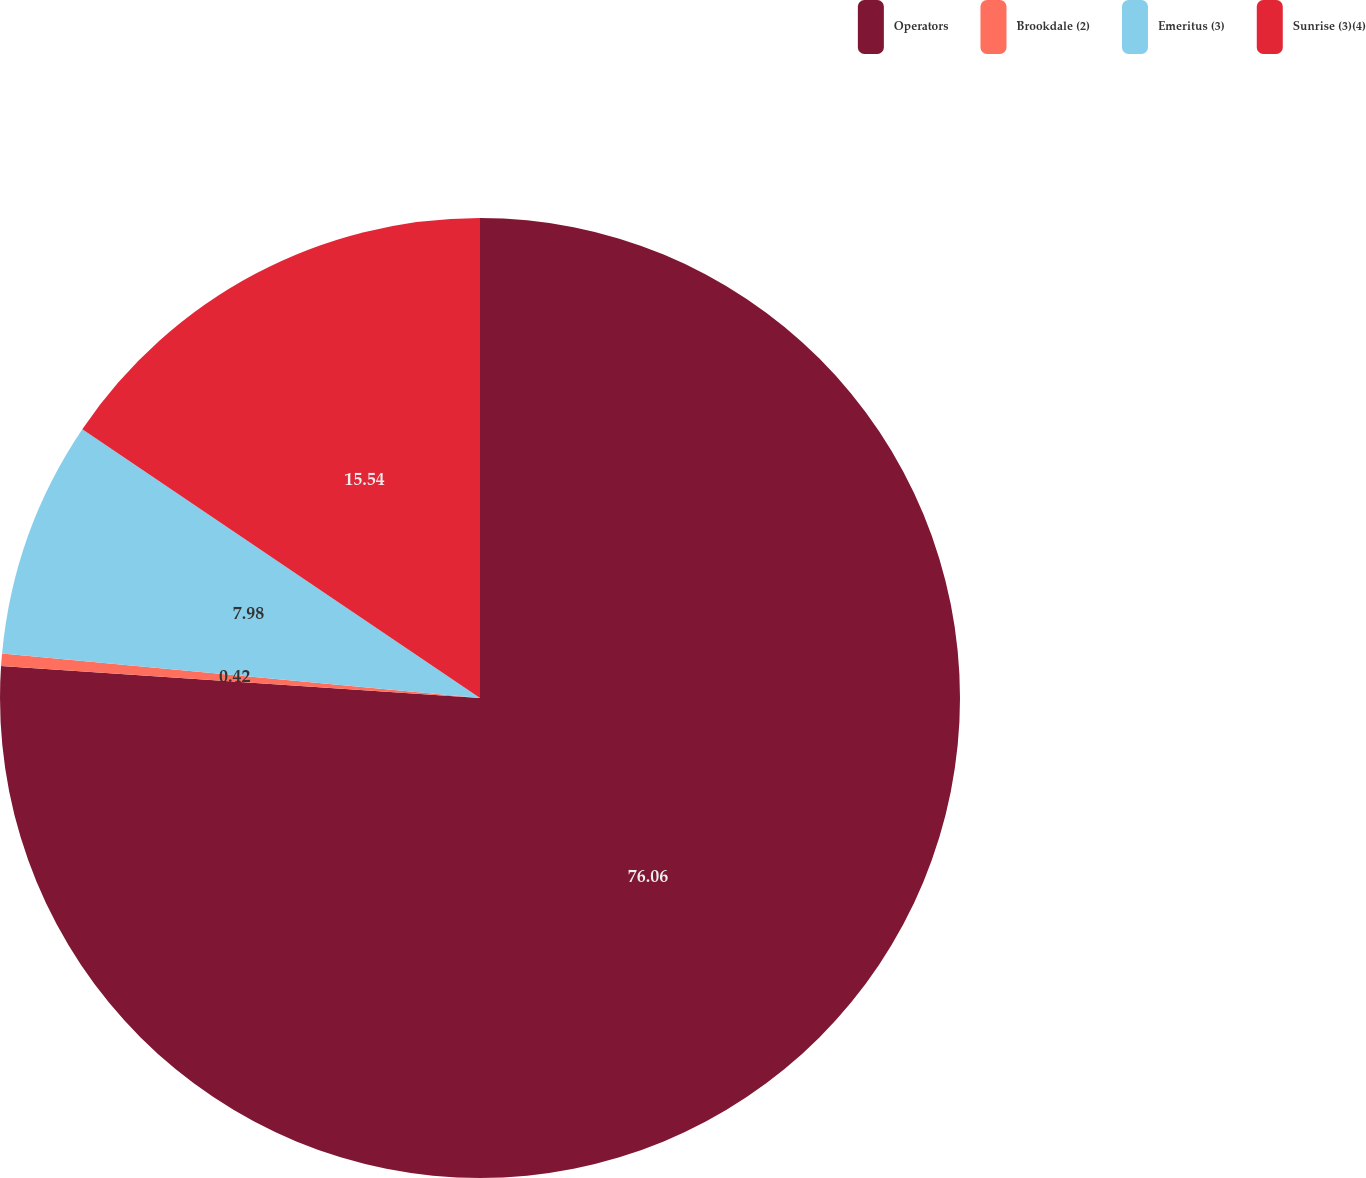<chart> <loc_0><loc_0><loc_500><loc_500><pie_chart><fcel>Operators<fcel>Brookdale (2)<fcel>Emeritus (3)<fcel>Sunrise (3)(4)<nl><fcel>76.06%<fcel>0.42%<fcel>7.98%<fcel>15.54%<nl></chart> 